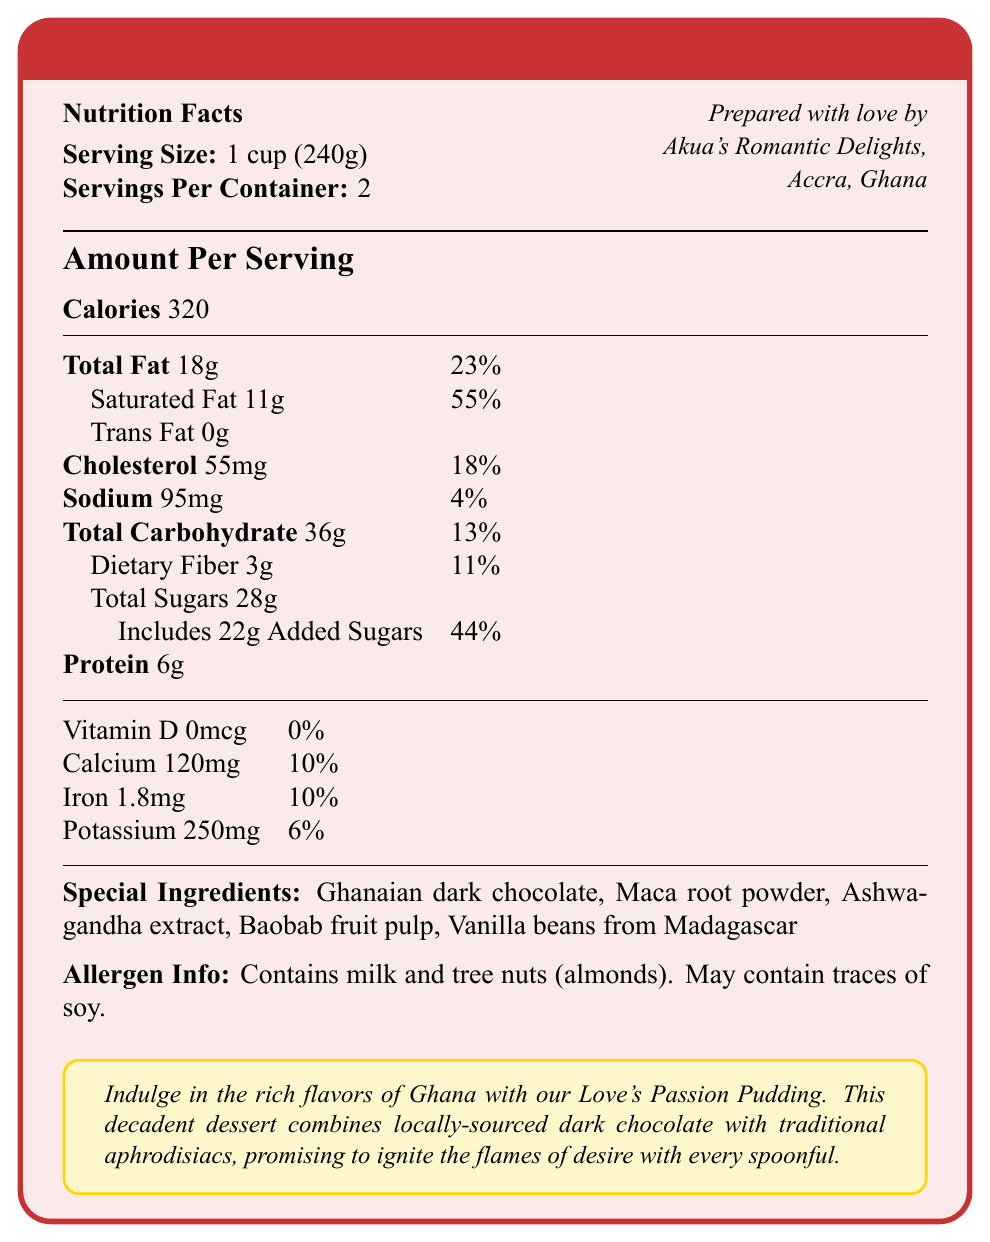what is the serving size? The serving size is directly stated in the document as "1 cup (240g)".
Answer: 1 cup (240g) how many calories are in one serving of Love's Passion Pudding? The document lists the calories per serving as 320.
Answer: 320 how much total fat is in a serving? The document states that the total fat per serving is 18g.
Answer: 18g what are the saturated fat and its daily value percentage? The document specifies that saturated fat is 11g which corresponds to 55% of the daily value.
Answer: 11g, 55% what is the total carbohydrate content per serving? The total carbohydrate content per serving is listed as 36g in the document.
Answer: 36g how much iron does one serving provide? The iron content per serving is 1.8mg, as stated in the document.
Answer: 1.8mg which of these ingredients is not in Love's Passion Pudding? A. Maca root powder B. Baobab fruit pulp C. Mango extract D. Ghanaian dark chocolate The document lists Maca root powder, Baobab fruit pulp, and Ghanaian dark chocolate as ingredients, but not Mango extract.
Answer: C By what percentage does the sodium content of Love's Passion Pudding contribute to the daily value? The sodium content per serving contributes 4% to the daily value as per the document.
Answer: 4% how much protein is in a serving? The document states that each serving contains 6g of protein.
Answer: 6g what is the special romantic description provided for Love's Passion Pudding? The document includes a special romantic description highlighting the flavors and aphrodisiac ingredients promising to ignite the flames of desire.
Answer: Indulge in the rich flavors of Ghana with our Love's Passion Pudding. This decadent dessert combines locally-sourced dark chocolate with traditional aphrodisiacs, promising to ignite the flames of desire with every spoonful. what are the allergen contents mentioned? A. Milk and tree nuts (almonds) B. Soy and tree nuts (almonds) C. Milk and gluten D. Peanut and tree nuts (almonds) The document states that it contains milk and tree nuts (almonds) and may contain traces of soy.
Answer: A does this dessert contain any cholesterol? The document lists the cholesterol content as 55mg per serving.
Answer: Yes Summarize the entire document. The document provides detailed nutrition information for Love's Passion Pudding, highlighting its calorie content, fat, cholesterol, sodium, carbohydrates, and protein. It also lists special aphrodisiac ingredients, allergen information, and is prepared by Akua's Romantic Delights in Accra, Ghana. The romantic description emphasizes the dessert's rich flavors and sensual attributes.
Answer: Love's Passion Pudding is a romantic-themed dessert with aphrodisiac ingredients like Ghanaian dark chocolate and Maca root powder. It contains 320 calories per serving, with significant amounts of fat, sodium, carbohydrates, and protein. The allergen information reveals the presence of milk and tree nuts (almonds). It's prepared by Akua's Romantic Delights in Ghana. how many servings are in the entire container? The document states "Servings Per Container: 2".
Answer: 2 Based on the romantic setting described, where could you imagine sharing this dessert with a partner? The document suggests that the dessert is perfect for a steamy scene set in a luxurious Accra hotel, indicating an ideal romantic setting.
Answer: In a luxurious Accra hotel. does Love's Passion Pudding contain any vitamin D? The document states that the Vitamin D content is 0mcg, contributing to 0% of the daily value.
Answer: No How can it be determined whether the dessert can assist in muscle recovery? The document does not state any functional claims about muscle recovery or its relevant nutritional components, so this cannot be determined.
Answer: Not enough information 